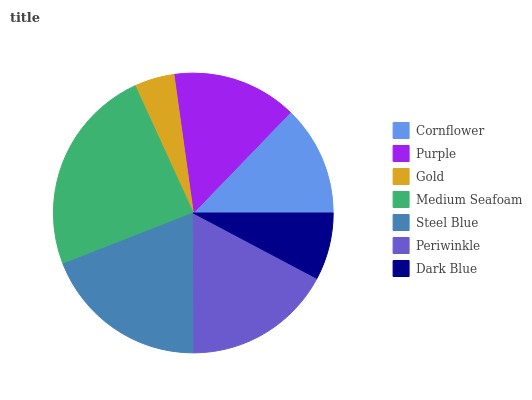Is Gold the minimum?
Answer yes or no. Yes. Is Medium Seafoam the maximum?
Answer yes or no. Yes. Is Purple the minimum?
Answer yes or no. No. Is Purple the maximum?
Answer yes or no. No. Is Purple greater than Cornflower?
Answer yes or no. Yes. Is Cornflower less than Purple?
Answer yes or no. Yes. Is Cornflower greater than Purple?
Answer yes or no. No. Is Purple less than Cornflower?
Answer yes or no. No. Is Purple the high median?
Answer yes or no. Yes. Is Purple the low median?
Answer yes or no. Yes. Is Dark Blue the high median?
Answer yes or no. No. Is Medium Seafoam the low median?
Answer yes or no. No. 